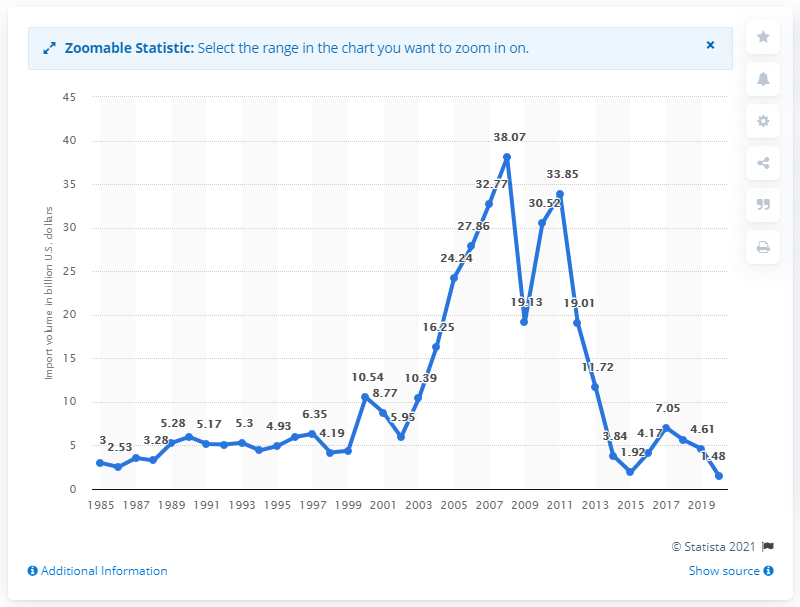Give some essential details in this illustration. The value of imports from Nigeria in dollars in 2020 was 1.48. 